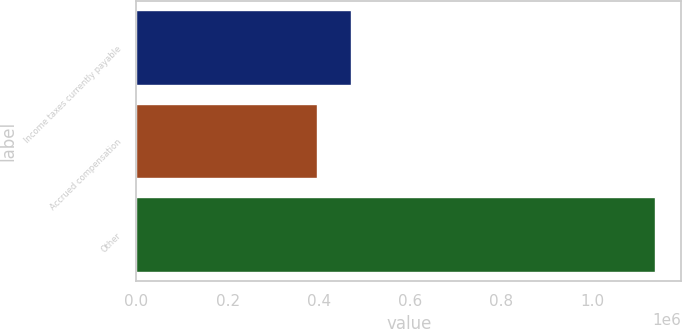Convert chart to OTSL. <chart><loc_0><loc_0><loc_500><loc_500><bar_chart><fcel>Income taxes currently payable<fcel>Accrued compensation<fcel>Other<nl><fcel>470715<fcel>396614<fcel>1.13762e+06<nl></chart> 